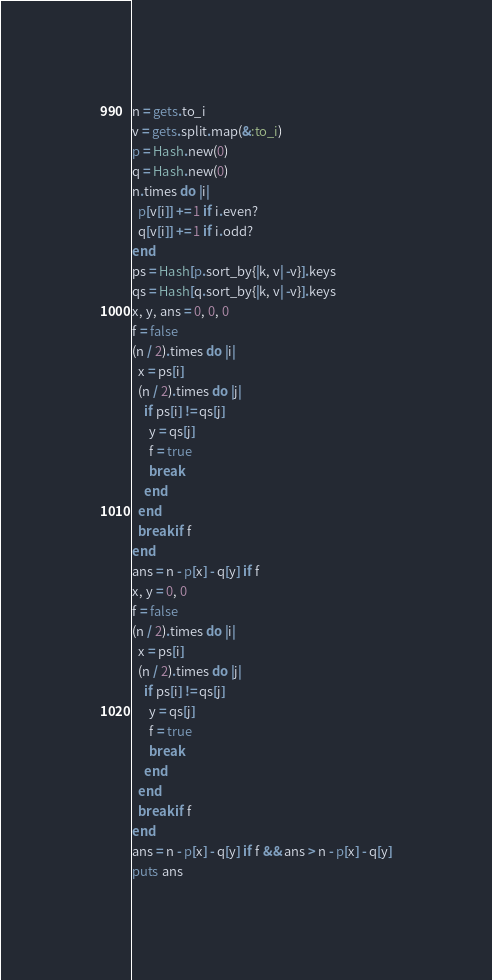<code> <loc_0><loc_0><loc_500><loc_500><_Ruby_>n = gets.to_i
v = gets.split.map(&:to_i)
p = Hash.new(0)
q = Hash.new(0)
n.times do |i|
  p[v[i]] += 1 if i.even?
  q[v[i]] += 1 if i.odd?
end
ps = Hash[p.sort_by{|k, v| -v}].keys
qs = Hash[q.sort_by{|k, v| -v}].keys
x, y, ans = 0, 0, 0
f = false
(n / 2).times do |i|
  x = ps[i]
  (n / 2).times do |j|
    if ps[i] != qs[j]
      y = qs[j]
      f = true
      break
    end
  end
  break if f
end
ans = n - p[x] - q[y] if f
x, y = 0, 0
f = false
(n / 2).times do |i|
  x = ps[i]
  (n / 2).times do |j|
    if ps[i] != qs[j]
      y = qs[j]
      f = true
      break
    end
  end
  break if f
end
ans = n - p[x] - q[y] if f && ans > n - p[x] - q[y]
puts ans</code> 